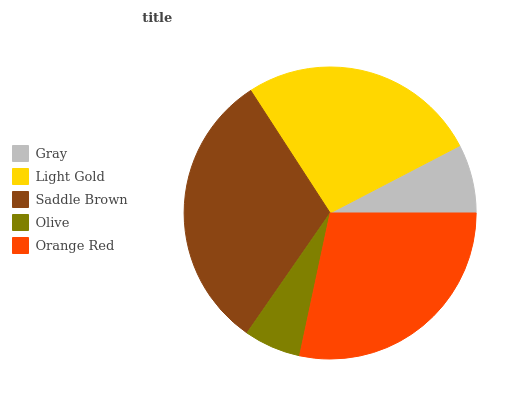Is Olive the minimum?
Answer yes or no. Yes. Is Saddle Brown the maximum?
Answer yes or no. Yes. Is Light Gold the minimum?
Answer yes or no. No. Is Light Gold the maximum?
Answer yes or no. No. Is Light Gold greater than Gray?
Answer yes or no. Yes. Is Gray less than Light Gold?
Answer yes or no. Yes. Is Gray greater than Light Gold?
Answer yes or no. No. Is Light Gold less than Gray?
Answer yes or no. No. Is Light Gold the high median?
Answer yes or no. Yes. Is Light Gold the low median?
Answer yes or no. Yes. Is Orange Red the high median?
Answer yes or no. No. Is Gray the low median?
Answer yes or no. No. 